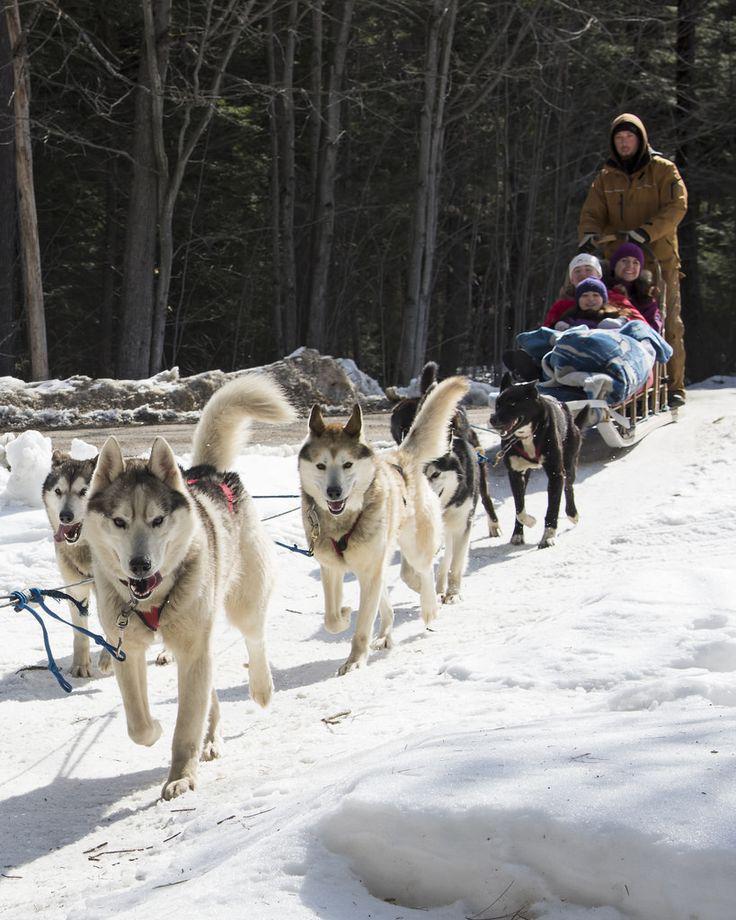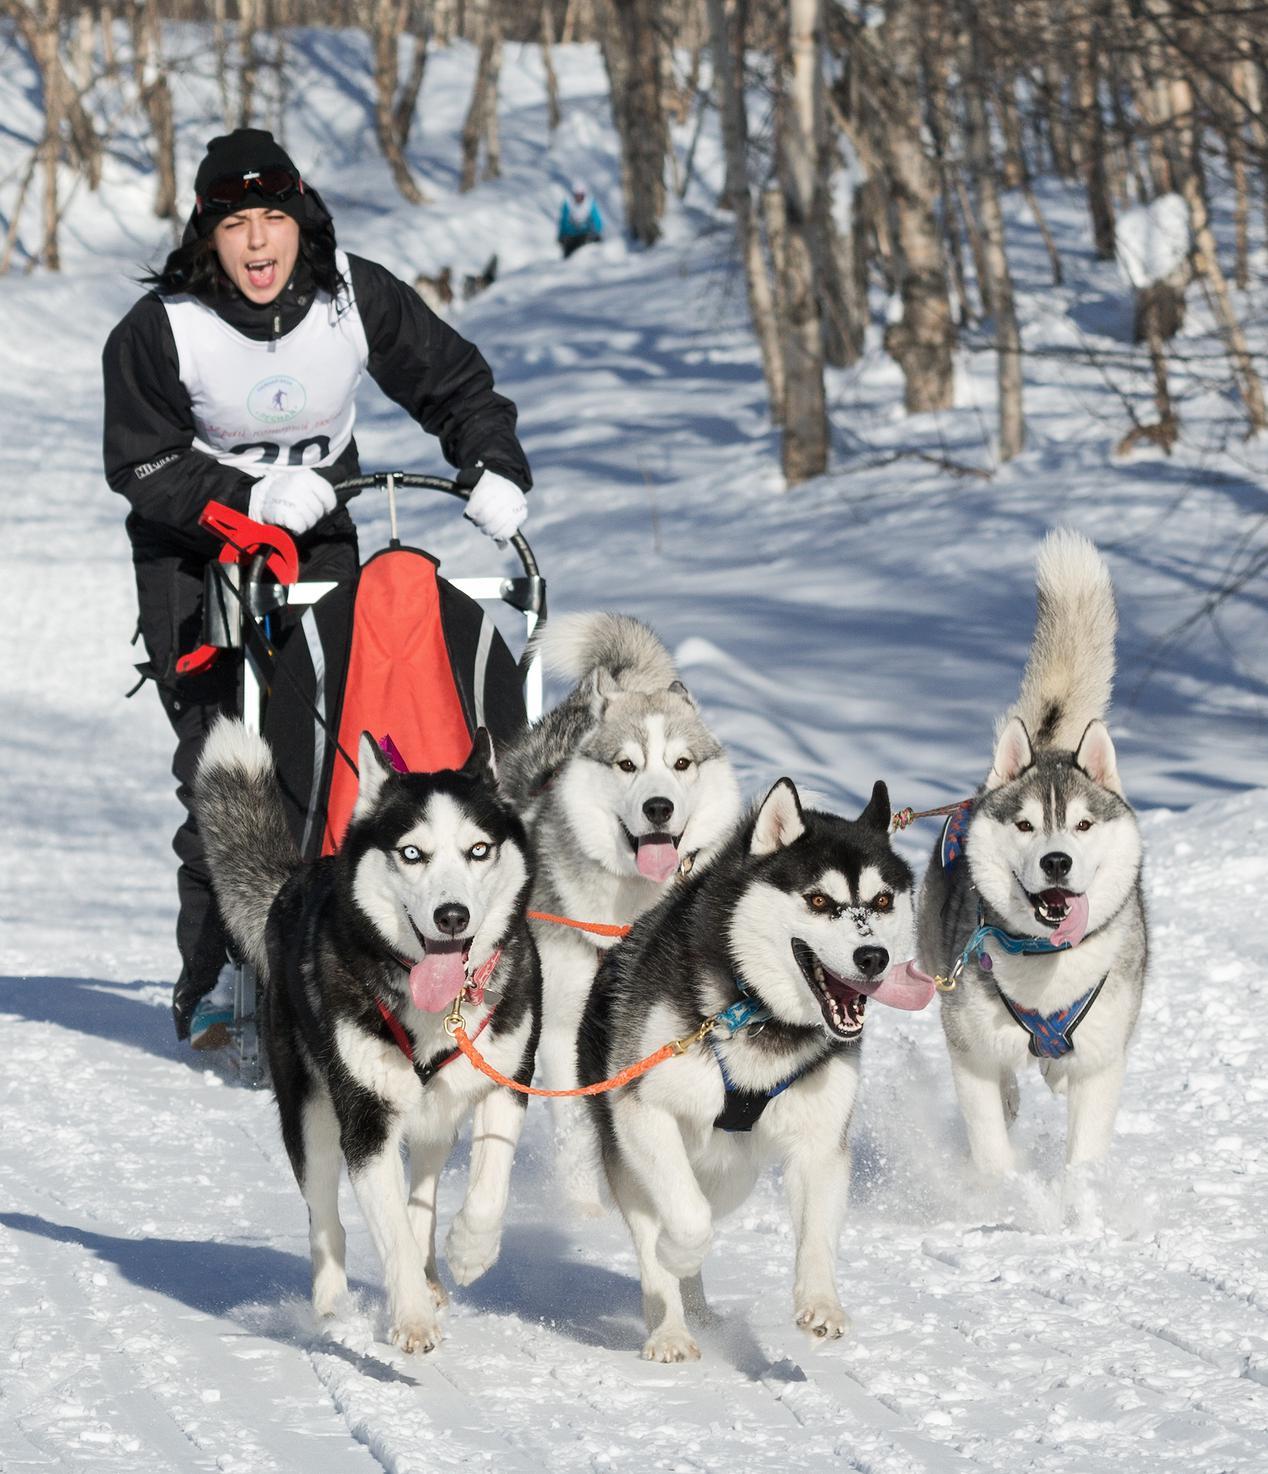The first image is the image on the left, the second image is the image on the right. Analyze the images presented: Is the assertion "There are 3 sled dogs pulling a sled" valid? Answer yes or no. No. The first image is the image on the left, the second image is the image on the right. Evaluate the accuracy of this statement regarding the images: "In one image, three dogs pulling a sled are visible.". Is it true? Answer yes or no. No. 